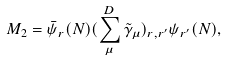Convert formula to latex. <formula><loc_0><loc_0><loc_500><loc_500>M _ { 2 } = \bar { \psi } _ { r } ( N ) ( \sum _ { \mu } ^ { D } \tilde { \gamma } _ { \mu } ) _ { r , r ^ { \prime } } \psi _ { r ^ { \prime } } ( N ) ,</formula> 